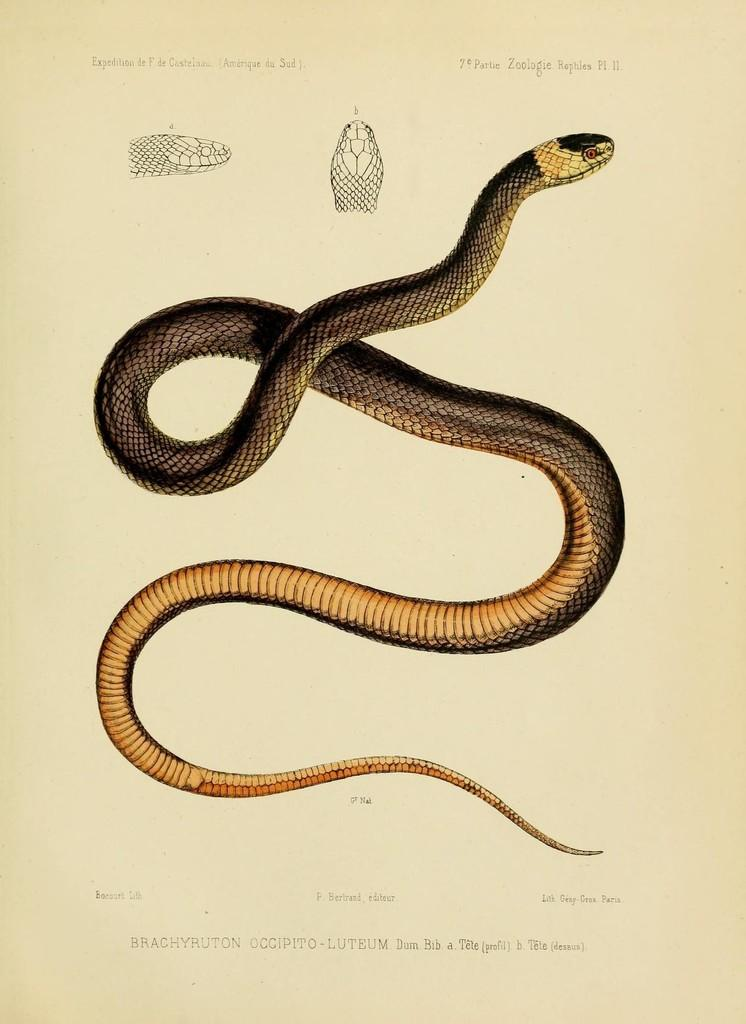What is the main subject of the image? The main subject of the image is a diagram of a snake. What else is present in the image besides the snake diagram? There is text in the image. What type of sweater is the snake wearing in the image? There is no sweater present in the image, as it is a diagram of a snake and not a living creature. What grade did the snake receive on its report card in the image? There is no report card or grade mentioned in the image, as it is a diagram of a snake and not a student. 